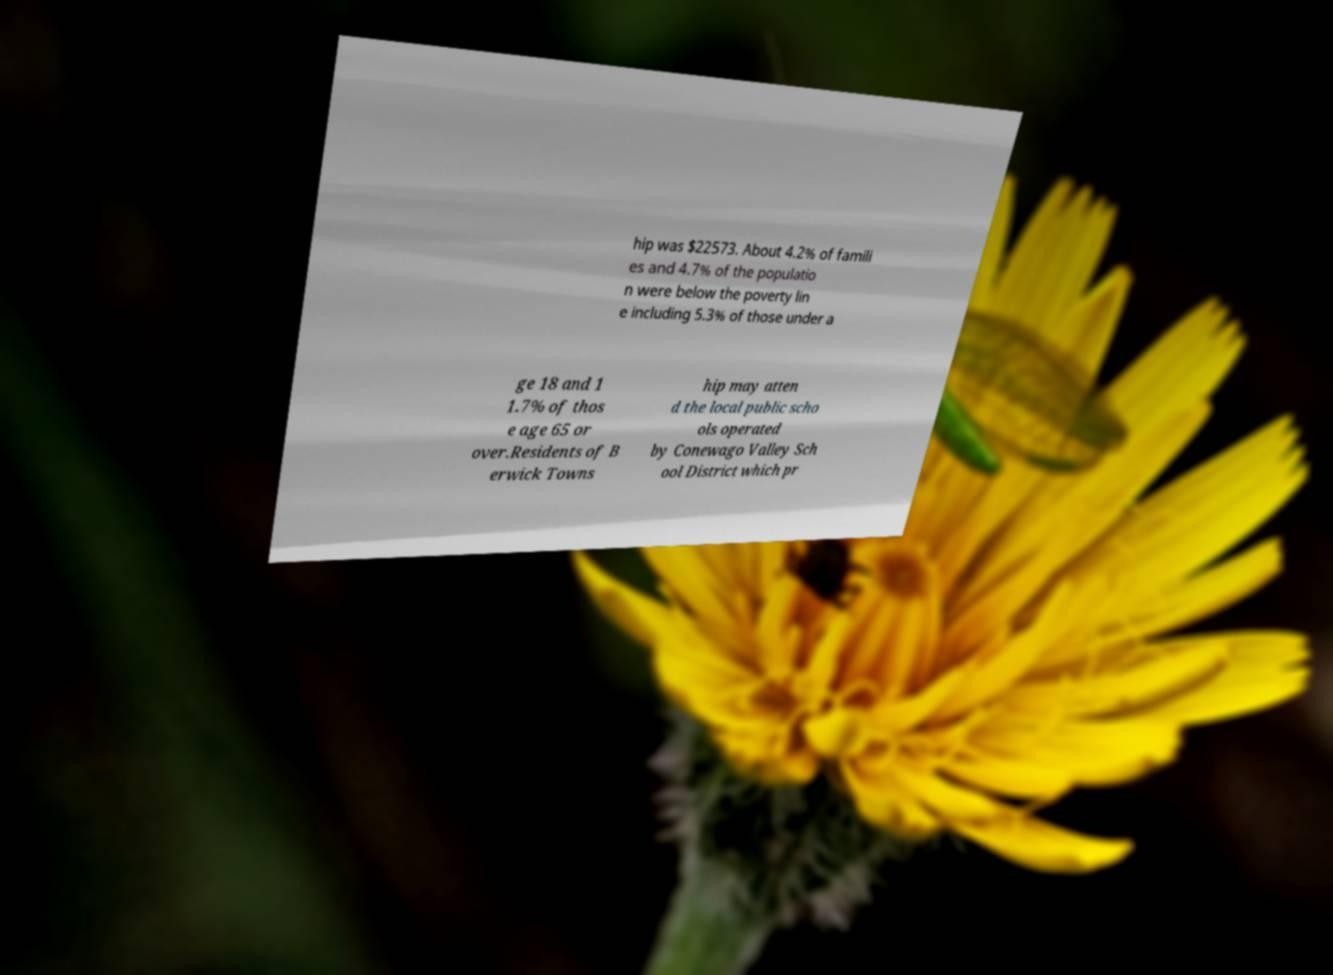Can you read and provide the text displayed in the image?This photo seems to have some interesting text. Can you extract and type it out for me? hip was $22573. About 4.2% of famili es and 4.7% of the populatio n were below the poverty lin e including 5.3% of those under a ge 18 and 1 1.7% of thos e age 65 or over.Residents of B erwick Towns hip may atten d the local public scho ols operated by Conewago Valley Sch ool District which pr 